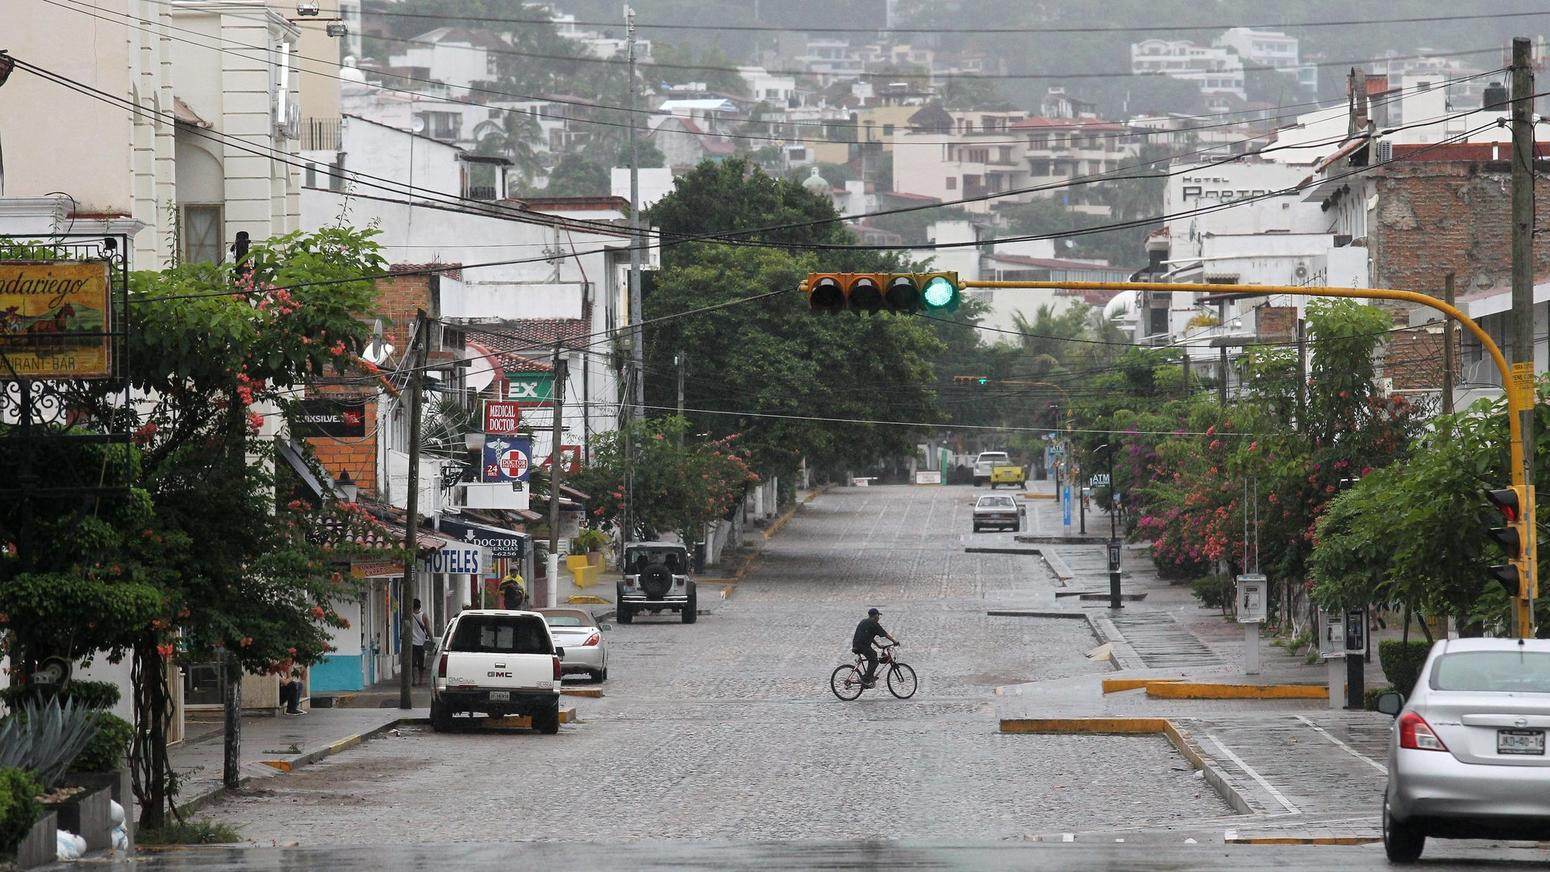Given the weather conditions, how might businesses adapt their services on such a rainy day? In response to the rainy weather, local businesses might adapt by providing sheltered areas for patrons waiting outside, offering dry spots for bicycles and motorbikes commonly used for transportation in such locales, and perhaps promoting cozy, rain-friendly indoors services like warm drinks or rain gear rentals. It's also possible that delivery services become more popular as residents may prefer to stay indoors, leading businesses to enhance their takeaway or home delivery options. 